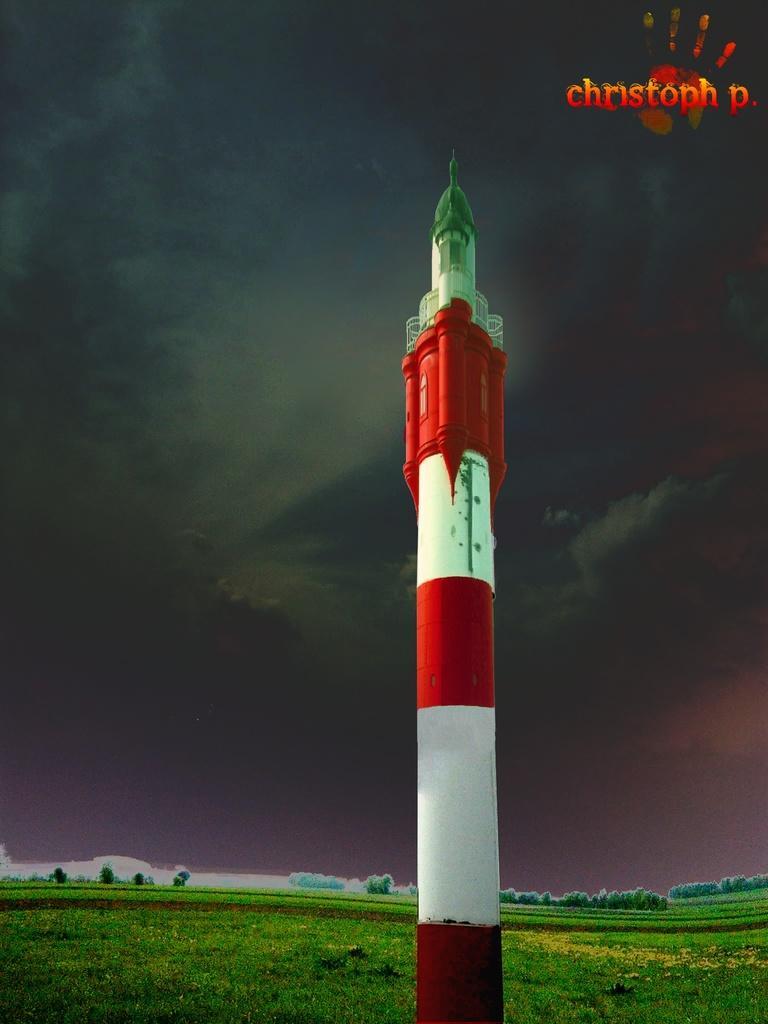Please provide a concise description of this image. In the center of the image, we can see a rocket and at the bottom, there are trees and there is ground. At the top, there is some text and we can see smoke in the sky. 